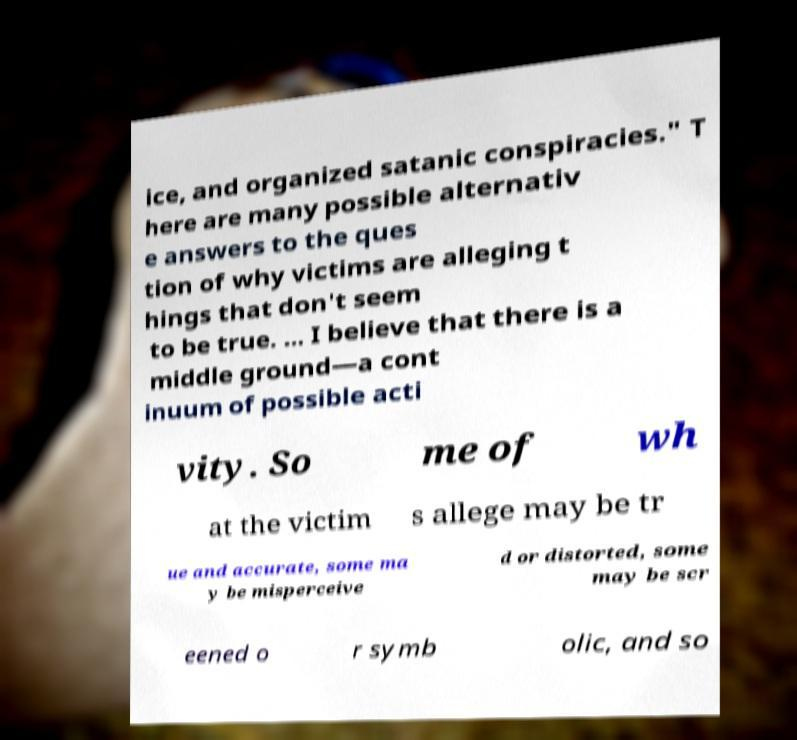Can you accurately transcribe the text from the provided image for me? ice, and organized satanic conspiracies." T here are many possible alternativ e answers to the ques tion of why victims are alleging t hings that don't seem to be true. ... I believe that there is a middle ground—a cont inuum of possible acti vity. So me of wh at the victim s allege may be tr ue and accurate, some ma y be misperceive d or distorted, some may be scr eened o r symb olic, and so 